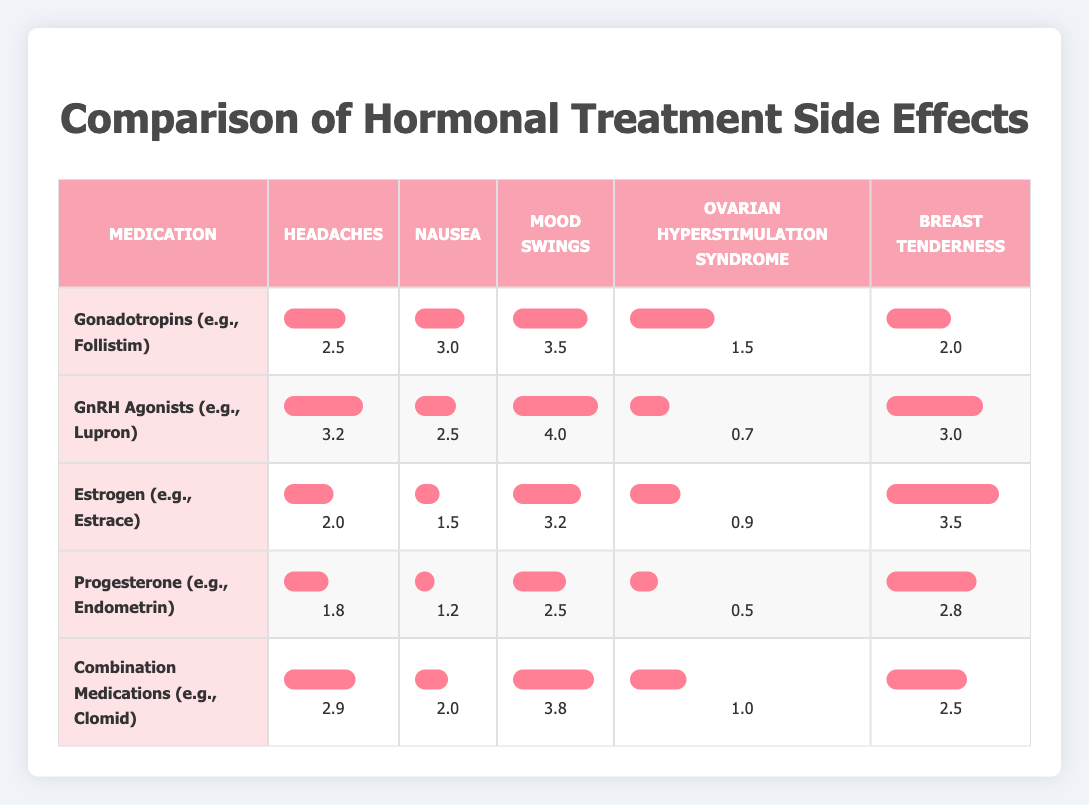What is the highest value for mood swings among the medications? By examining the "Mood Swings" column in the table, the highest value listed is 4.0, which corresponds to the medication "GnRH Agonists (e.g., Lupron)."
Answer: 4.0 Which medication has the lowest reported side effect for nausea? Looking at the "Nausea" column, the lowest value is 1.2, which is associated with "Progesterone (e.g., Endometrin)."
Answer: 1.2 Are headaches reported more commonly with Gonadotropins than with Estrogen? The value for headaches in the Gonadotropins row is 2.5, while in the Estrogen row it is 2.0. Since 2.5 is greater than 2.0, yes, headaches are reported more commonly with Gonadotropins.
Answer: Yes What is the average value of ovarian hyperstimulation syndrome across all medications? The values for ovarian hyperstimulation syndrome are 1.5, 0.7, 0.9, 0.5, and 1.0. Adding these gives a total of 4.6, and dividing by the number of medications (5) provides the average: 4.6 / 5 = 0.92.
Answer: 0.92 Does Combination Medications have a higher score for breast tenderness than GnRH Agonists? The "Breast Tenderness" score for Combination Medications is 2.5, while for GnRH Agonists it is 3.0. Since 2.5 is less than 3.0, the statement is false.
Answer: No What is the total score for side effects (headaches, nausea, mood swings, ovarian hyperstimulation syndrome, and breast tenderness) for Estrogen? The scores for Estrogen are 2.0, 1.5, 3.2, 0.9, and 3.5. Adding these together results in 2.0 + 1.5 + 3.2 + 0.9 + 3.5 = 11.1.
Answer: 11.1 Is it true that Progesterone has the lowest score across all side effects? To verify, we need to check all scores for Progesterone: 1.8 (headaches), 1.2 (nausea), 2.5 (mood swings), 0.5 (ovarian hyperstimulation syndrome), and 2.8 (breast tenderness). Comparing these with other medications shows that other medications have higher scores in multiple categories, so the assertion is true.
Answer: Yes Which medication has the second highest score for headaches? The headache scores are 2.5 (Gonadotropins), 3.2 (GnRH Agonists), 2.0 (Estrogen), 1.8 (Progesterone), and 2.9 (Combination Medications). Arranging these, the second highest score is 2.9 from Combination Medications.
Answer: 2.9 